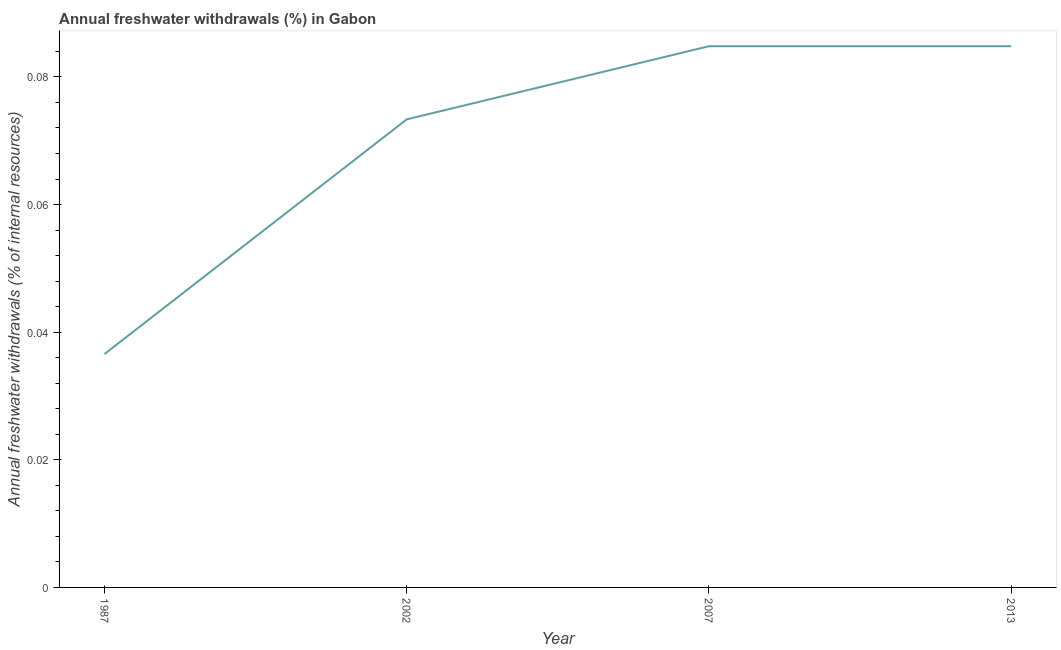What is the annual freshwater withdrawals in 2002?
Give a very brief answer. 0.07. Across all years, what is the maximum annual freshwater withdrawals?
Your answer should be very brief. 0.08. Across all years, what is the minimum annual freshwater withdrawals?
Give a very brief answer. 0.04. In which year was the annual freshwater withdrawals maximum?
Make the answer very short. 2007. What is the sum of the annual freshwater withdrawals?
Your response must be concise. 0.28. What is the difference between the annual freshwater withdrawals in 2007 and 2013?
Offer a very short reply. 0. What is the average annual freshwater withdrawals per year?
Provide a short and direct response. 0.07. What is the median annual freshwater withdrawals?
Provide a short and direct response. 0.08. Do a majority of the years between 2013 and 2007 (inclusive) have annual freshwater withdrawals greater than 0.028 %?
Offer a terse response. No. Is the difference between the annual freshwater withdrawals in 1987 and 2013 greater than the difference between any two years?
Keep it short and to the point. Yes. What is the difference between the highest and the second highest annual freshwater withdrawals?
Ensure brevity in your answer.  0. Is the sum of the annual freshwater withdrawals in 1987 and 2002 greater than the maximum annual freshwater withdrawals across all years?
Make the answer very short. Yes. What is the difference between the highest and the lowest annual freshwater withdrawals?
Make the answer very short. 0.05. In how many years, is the annual freshwater withdrawals greater than the average annual freshwater withdrawals taken over all years?
Offer a terse response. 3. How many years are there in the graph?
Offer a very short reply. 4. Does the graph contain grids?
Provide a short and direct response. No. What is the title of the graph?
Offer a very short reply. Annual freshwater withdrawals (%) in Gabon. What is the label or title of the Y-axis?
Provide a succinct answer. Annual freshwater withdrawals (% of internal resources). What is the Annual freshwater withdrawals (% of internal resources) in 1987?
Make the answer very short. 0.04. What is the Annual freshwater withdrawals (% of internal resources) of 2002?
Keep it short and to the point. 0.07. What is the Annual freshwater withdrawals (% of internal resources) of 2007?
Keep it short and to the point. 0.08. What is the Annual freshwater withdrawals (% of internal resources) in 2013?
Your answer should be compact. 0.08. What is the difference between the Annual freshwater withdrawals (% of internal resources) in 1987 and 2002?
Ensure brevity in your answer.  -0.04. What is the difference between the Annual freshwater withdrawals (% of internal resources) in 1987 and 2007?
Your answer should be very brief. -0.05. What is the difference between the Annual freshwater withdrawals (% of internal resources) in 1987 and 2013?
Give a very brief answer. -0.05. What is the difference between the Annual freshwater withdrawals (% of internal resources) in 2002 and 2007?
Provide a short and direct response. -0.01. What is the difference between the Annual freshwater withdrawals (% of internal resources) in 2002 and 2013?
Your answer should be compact. -0.01. What is the ratio of the Annual freshwater withdrawals (% of internal resources) in 1987 to that in 2002?
Your answer should be compact. 0.5. What is the ratio of the Annual freshwater withdrawals (% of internal resources) in 1987 to that in 2007?
Offer a very short reply. 0.43. What is the ratio of the Annual freshwater withdrawals (% of internal resources) in 1987 to that in 2013?
Make the answer very short. 0.43. What is the ratio of the Annual freshwater withdrawals (% of internal resources) in 2002 to that in 2007?
Offer a terse response. 0.86. What is the ratio of the Annual freshwater withdrawals (% of internal resources) in 2002 to that in 2013?
Offer a very short reply. 0.86. What is the ratio of the Annual freshwater withdrawals (% of internal resources) in 2007 to that in 2013?
Your answer should be very brief. 1. 